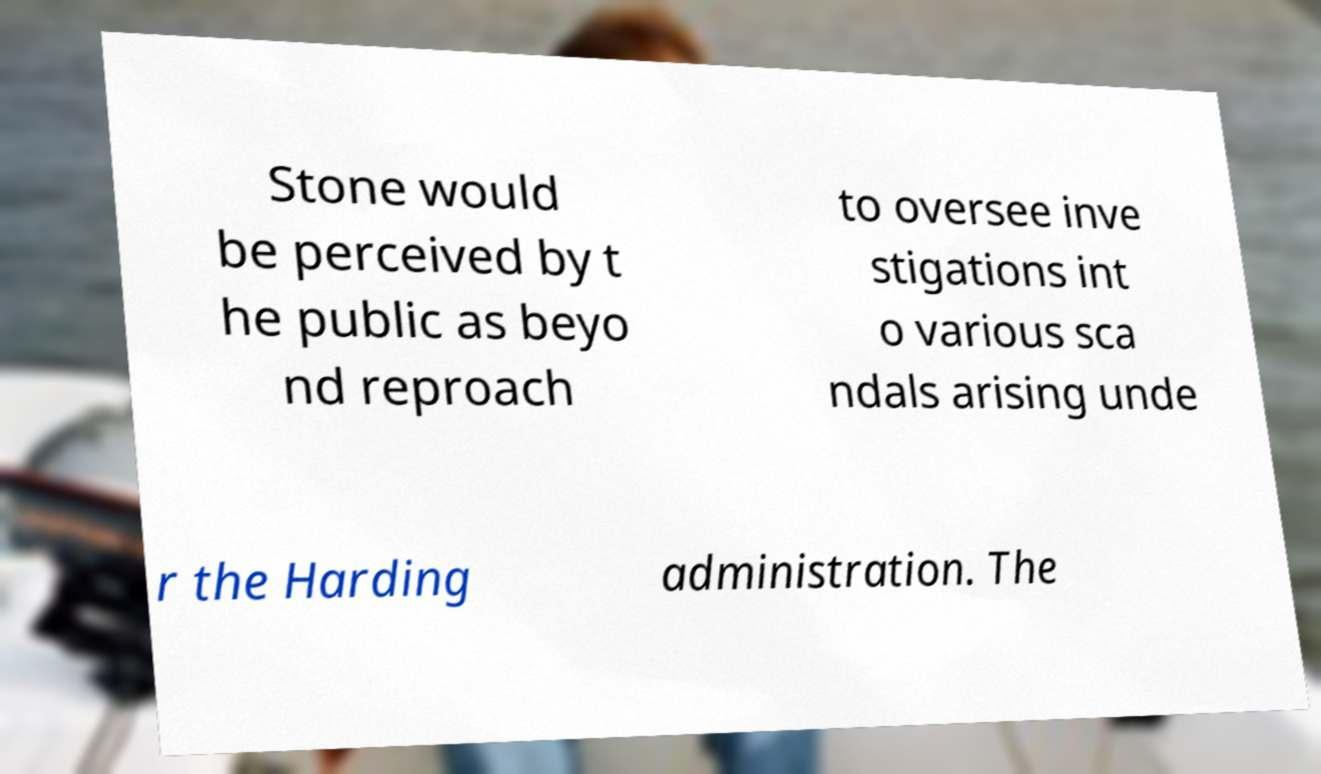What messages or text are displayed in this image? I need them in a readable, typed format. Stone would be perceived by t he public as beyo nd reproach to oversee inve stigations int o various sca ndals arising unde r the Harding administration. The 